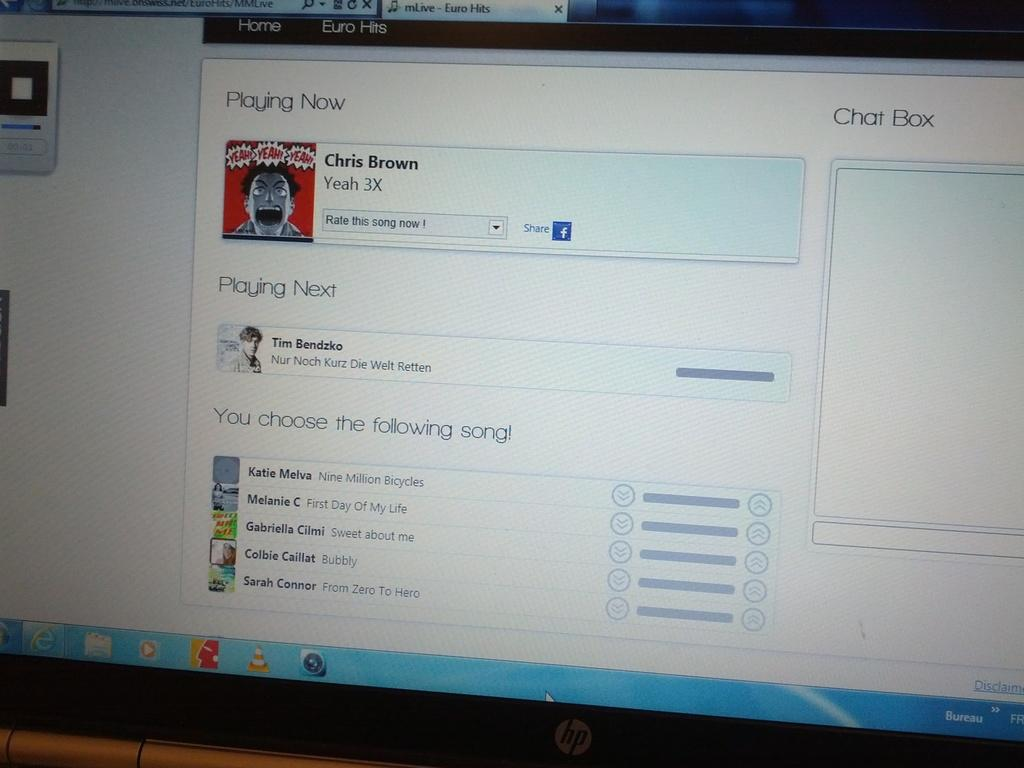<image>
Create a compact narrative representing the image presented. A computer monitor with a song by Chris Brown playing on the screen. 